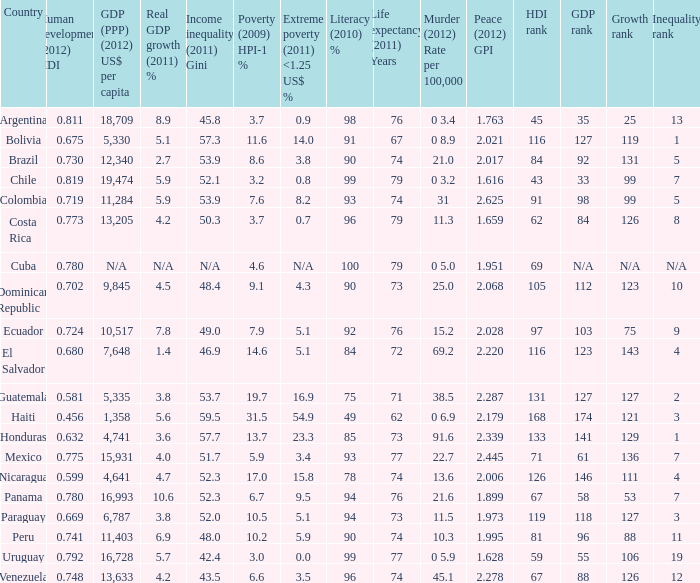What is the total poverty (2009) HPI-1 % when the extreme poverty (2011) <1.25 US$ % of 16.9, and the human development (2012) HDI is less than 0.581? None. 